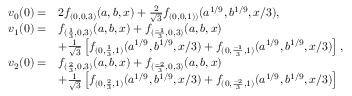Convert formula to latex. <formula><loc_0><loc_0><loc_500><loc_500>\begin{array} { r l } { v _ { 0 } ( 0 ) = } & { 2 f _ { ( 0 , 0 , 3 ) } ( a , b , x ) + \frac { 2 } { \sqrt { 3 } } f _ { ( 0 , 0 , 1 ) ) } ( a ^ { 1 / 9 } , b ^ { 1 / 9 } , x / 3 ) , } \\ { v _ { 1 } ( 0 ) = } & { f _ { ( \frac { 1 } { 3 } , 0 , 3 ) } ( a , b , x ) + f _ { ( \frac { - 1 } { 3 } , 0 , 3 ) } ( a , b , x ) } \\ & { + \frac { 1 } { \sqrt { 3 } } \left [ f _ { ( 0 , \frac { 1 } { 3 } , 1 ) } ( a ^ { 1 / 9 } , b ^ { 1 / 9 } , x / 3 ) + f _ { ( 0 , \frac { - 1 } { 3 } , 1 ) } ( a ^ { 1 / 9 } , b ^ { 1 / 9 } , x / 3 ) \right ] , } \\ { v _ { 2 } ( 0 ) = } & { f _ { ( \frac { 2 } { 3 } , 0 , 3 ) } ( a , b , x ) + f _ { ( \frac { - 2 } { 3 } , 0 , 3 ) } ( a , b , x ) } \\ & { + \frac { 1 } { \sqrt { 3 } } \left [ f _ { ( 0 , \frac { 2 } { 3 } , 1 ) } ( a ^ { 1 / 9 } , b ^ { 1 / 9 } , x / 3 ) + f _ { ( 0 , \frac { - 2 } { 3 } , 1 ) } ( a ^ { 1 / 9 } , b ^ { 1 / 9 } , x / 3 ) \right ] } \end{array}</formula> 